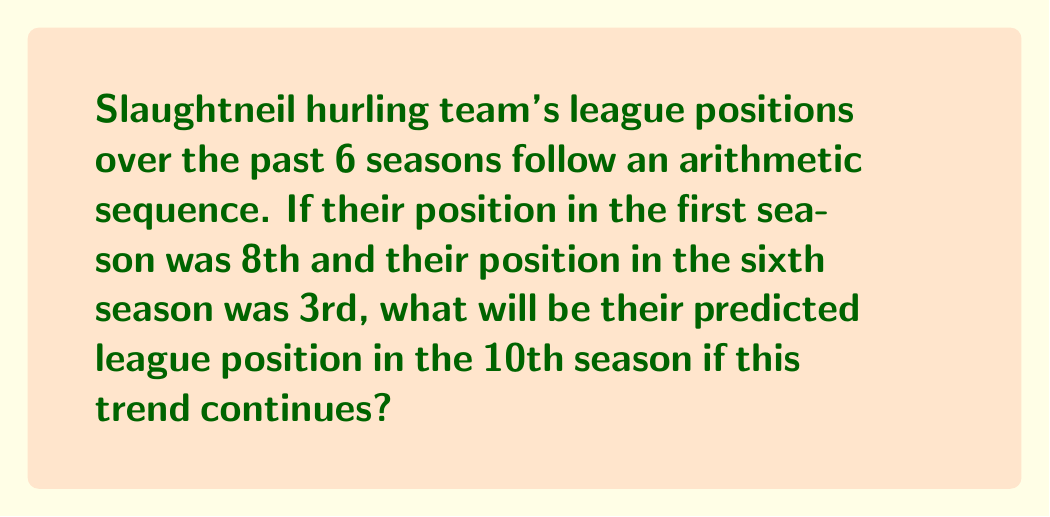Provide a solution to this math problem. Let's approach this step-by-step:

1) In an arithmetic sequence, the difference between each term is constant. Let's call this common difference $d$.

2) We know the first term $a_1 = 8$ and the sixth term $a_6 = 3$.

3) In an arithmetic sequence, the nth term is given by:
   $a_n = a_1 + (n-1)d$

4) We can use this to set up an equation:
   $3 = 8 + (6-1)d$
   $3 = 8 + 5d$

5) Solving for $d$:
   $-5 = 5d$
   $d = -1$

6) So, the sequence decreases by 1 each season.

7) Now, we can find the 10th term using the same formula:
   $a_{10} = a_1 + (10-1)d$
   $a_{10} = 8 + (9)(-1)$
   $a_{10} = 8 - 9 = -1$

8) However, league positions can't be negative. The lowest possible position is 1st.

9) Given the trend, Slaughtneil would reach 1st position in the 8th season and maintain that position thereafter.

Therefore, in the 10th season, Slaughtneil's predicted league position would be 1st.
Answer: 1st 